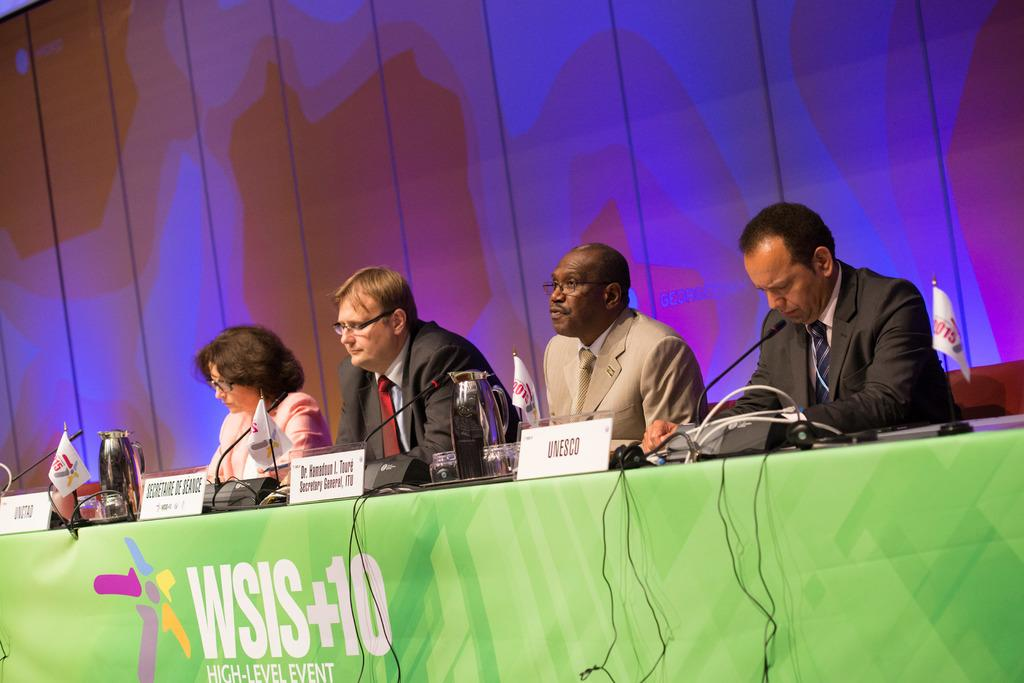What are the people in the image doing? The people in the image are seated. What objects can be seen on the table in the image? There are jars, name boards, microphones, and flags on the table in the image. What is hanging above the table in the image? There is a banner with text in the image. What type of silk fabric is draped over the chairs in the image? There is no silk fabric present in the image; the chairs are not draped with any fabric. 